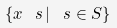<formula> <loc_0><loc_0><loc_500><loc_500>\{ x _ { \ } s \, | \, \ s \in S \}</formula> 